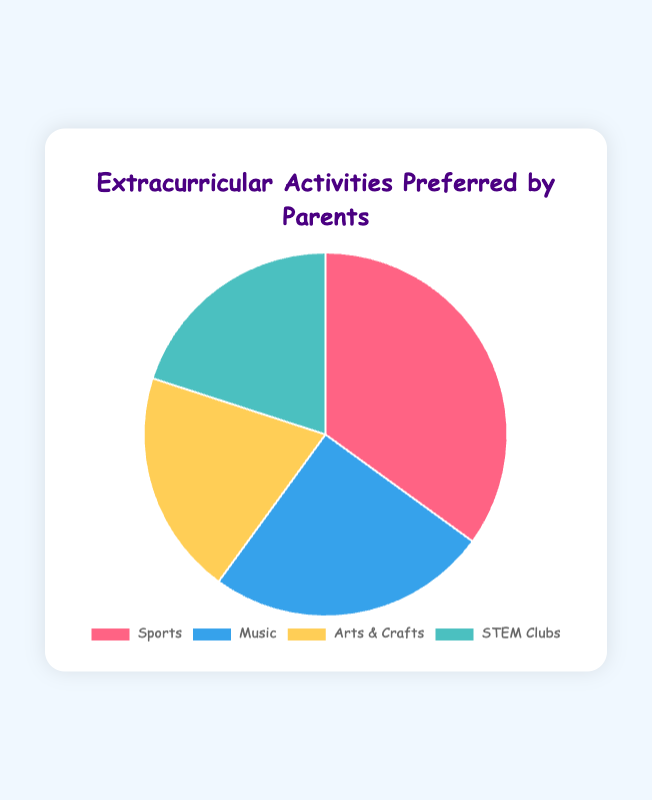What percentage of parents prefer STEM Clubs and Arts & Crafts combined? To find the combined preference for STEM Clubs and Arts & Crafts, add their percentages: 20% (STEM Clubs) + 20% (Arts & Crafts) = 40%.
Answer: 40% Which extracurricular activity is the most preferred by parents? The most preferred activity has the highest percentage. In the chart, Sports has 35%, which is the highest among all activities.
Answer: Sports Is the percentage of parents preferring Music greater than those preferring STEM Clubs? Compare the percentages: Music is 25% and STEM Clubs is 20%. Since 25% > 20%, more parents prefer Music over STEM Clubs.
Answer: Yes How much more popular is Sports compared to Arts & Crafts? Subtract the percentage of Arts & Crafts from Sports: 35% (Sports) - 20% (Arts & Crafts) = 15%.
Answer: 15% Which two activities have the same percentage of parental preference? Look for activities with the same percentage. Both Arts & Crafts and STEM Clubs have 20%.
Answer: Arts & Crafts and STEM Clubs What fraction of parents prefer either Sports or Music? Add the percentages of Sports and Music: 35% (Sports) + 25% (Music) = 60%. The fraction representing this is 60/100, which simplifies to 3/5.
Answer: 3/5 Rank the extracurricular activities from most preferred to least preferred. List the activities in descending order of their percentages: Sports (35%), Music (25%), Arts & Crafts (20%), STEM Clubs (20%).
Answer: Sports, Music, Arts & Crafts, STEM Clubs Which activity has the least interest from parents based on the chart? Identify the activity with the smallest percentage. Both Arts & Crafts and STEM Clubs have the smallest, but the question asks for a single activity, so either one can be named.
Answer: Arts & Crafts or STEM Clubs 